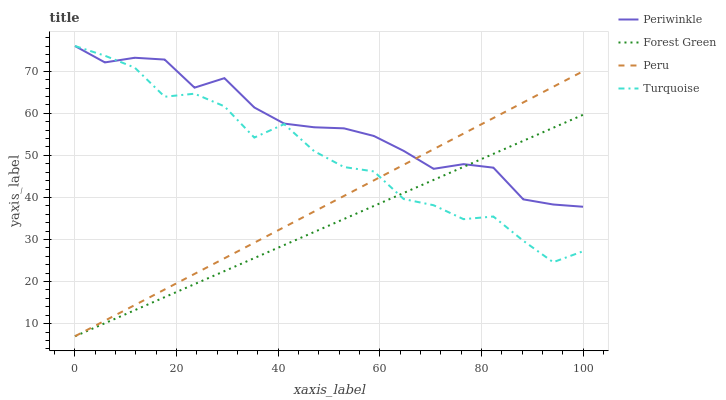Does Forest Green have the minimum area under the curve?
Answer yes or no. Yes. Does Periwinkle have the maximum area under the curve?
Answer yes or no. Yes. Does Turquoise have the minimum area under the curve?
Answer yes or no. No. Does Turquoise have the maximum area under the curve?
Answer yes or no. No. Is Forest Green the smoothest?
Answer yes or no. Yes. Is Turquoise the roughest?
Answer yes or no. Yes. Is Periwinkle the smoothest?
Answer yes or no. No. Is Periwinkle the roughest?
Answer yes or no. No. Does Forest Green have the lowest value?
Answer yes or no. Yes. Does Turquoise have the lowest value?
Answer yes or no. No. Does Turquoise have the highest value?
Answer yes or no. Yes. Does Peru have the highest value?
Answer yes or no. No. Does Peru intersect Forest Green?
Answer yes or no. Yes. Is Peru less than Forest Green?
Answer yes or no. No. Is Peru greater than Forest Green?
Answer yes or no. No. 